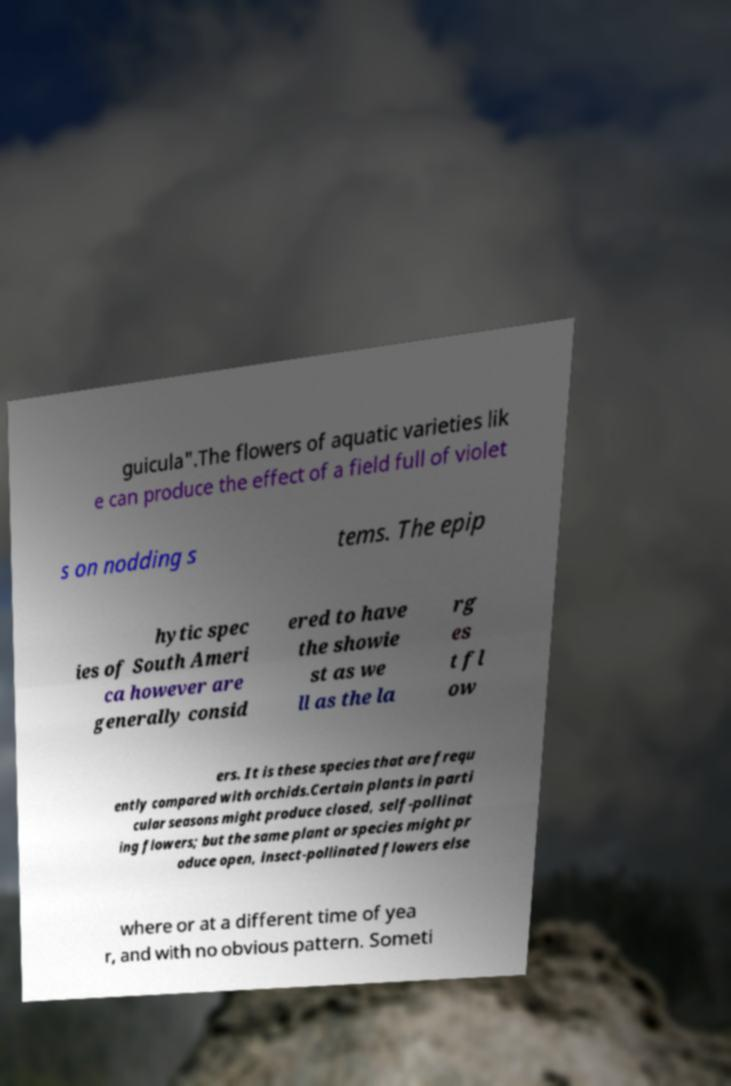What messages or text are displayed in this image? I need them in a readable, typed format. guicula".The flowers of aquatic varieties lik e can produce the effect of a field full of violet s on nodding s tems. The epip hytic spec ies of South Ameri ca however are generally consid ered to have the showie st as we ll as the la rg es t fl ow ers. It is these species that are frequ ently compared with orchids.Certain plants in parti cular seasons might produce closed, self-pollinat ing flowers; but the same plant or species might pr oduce open, insect-pollinated flowers else where or at a different time of yea r, and with no obvious pattern. Someti 